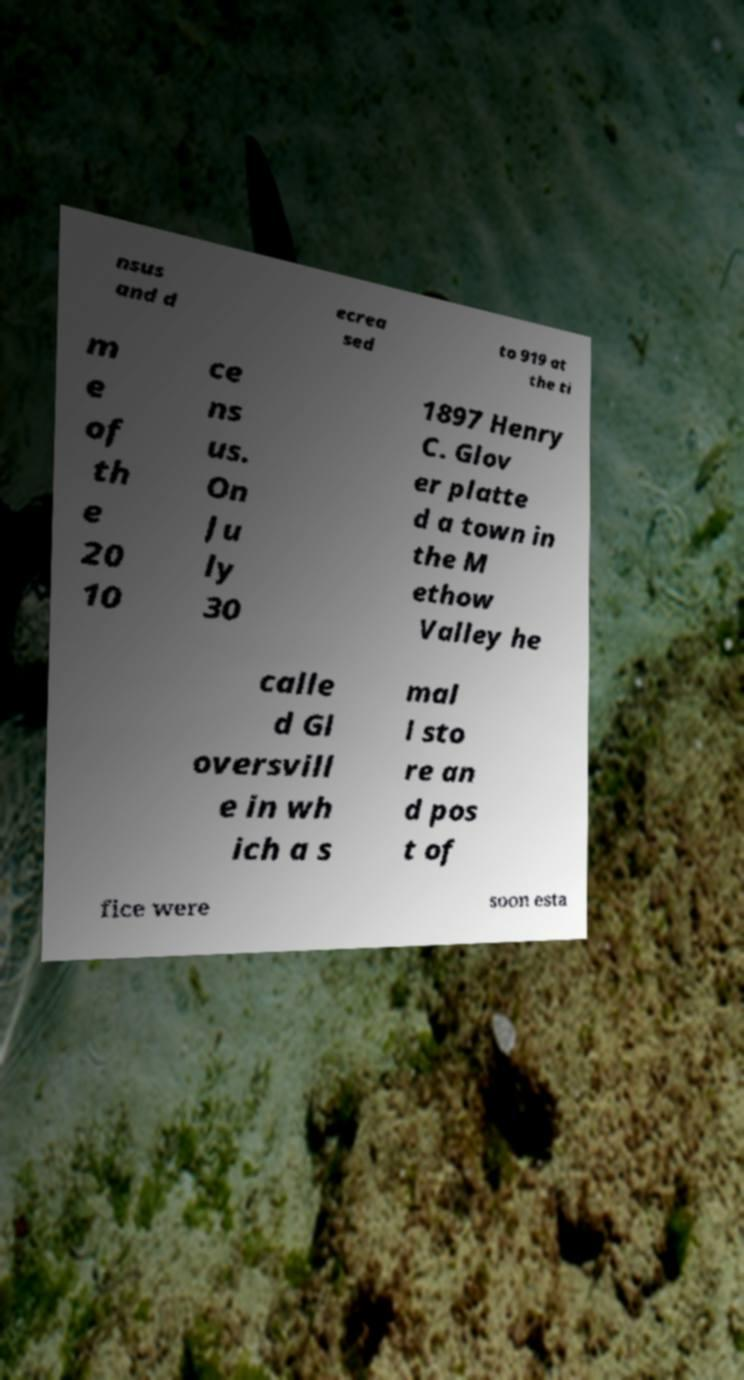Please read and relay the text visible in this image. What does it say? nsus and d ecrea sed to 919 at the ti m e of th e 20 10 ce ns us. On Ju ly 30 1897 Henry C. Glov er platte d a town in the M ethow Valley he calle d Gl oversvill e in wh ich a s mal l sto re an d pos t of fice were soon esta 